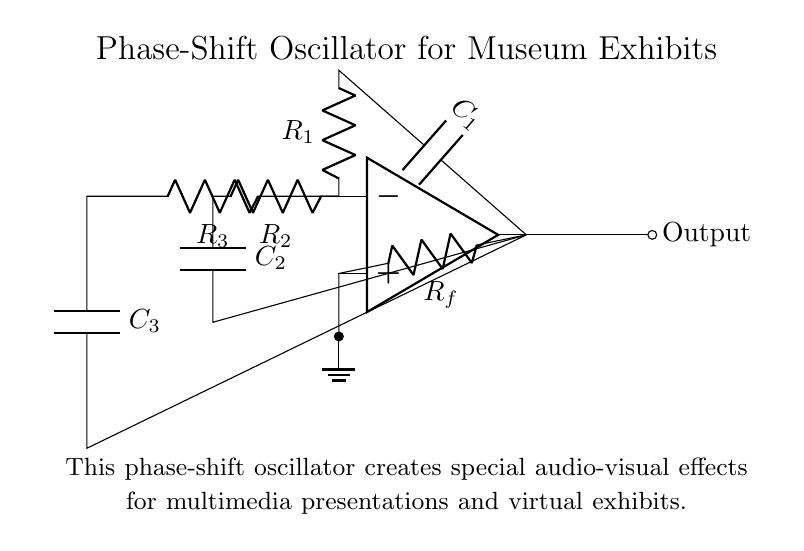What type of oscillator is shown in the circuit? The circuit is identified as a phase-shift oscillator, which is used to generate sinusoidal waveforms. This is indicated by its title and the phase-shift configuration involving RC components.
Answer: phase-shift oscillator How many resistors are present in the circuit? The circuit includes three distinct resistors: R1, R2, and R3. This can be determined by counting each labeled resistor in the diagram.
Answer: three What is the primary purpose of this phase-shift oscillator? The primary purpose is to create special audio-visual effects for multimedia presentations and virtual exhibits, as described in the circuit's overview.
Answer: audio-visual effects Which components are involved in feedback? The feedback in this circuit involves the resistor Rf, which connects the output back to the inverting input of the op-amp. This feedback is essential for stabilizing the oscillator's output.
Answer: Rf What is the role of capacitors in the oscillator? The capacitors (C1, C2, C3) in the circuit work alongside the resistors to create the necessary phase shifts required for oscillation, contributing to the timing and frequency of the output waveform.
Answer: phase shifts How does the configuration of resistors and capacitors affect the frequency of oscillation? The frequency of oscillation is determined by the values of R1, R2, R3, C1, C2, and C3. Each RC network provides a specific phase shift, and the total phase shift must equal 180 degrees for the circuit to oscillate. The frequency can be calculated based on these components.
Answer: affects frequency What is the output of this oscillator? The output of this phase-shift oscillator is an oscillating signal generated at the output node of the op-amp, which is used to create effects in multimedia presentations.
Answer: oscillating signal 